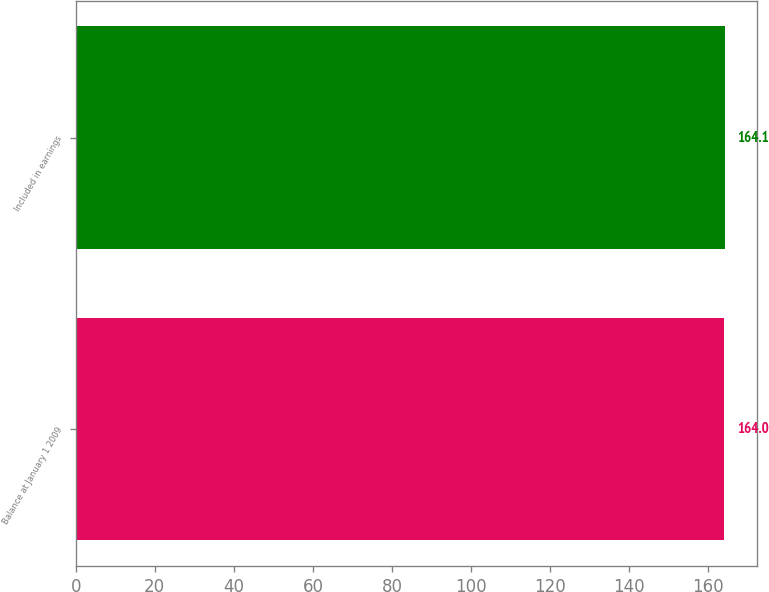Convert chart. <chart><loc_0><loc_0><loc_500><loc_500><bar_chart><fcel>Balance at January 1 2009<fcel>Included in earnings<nl><fcel>164<fcel>164.1<nl></chart> 